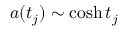<formula> <loc_0><loc_0><loc_500><loc_500>a ( t _ { j } ) \sim \cosh { t _ { j } }</formula> 